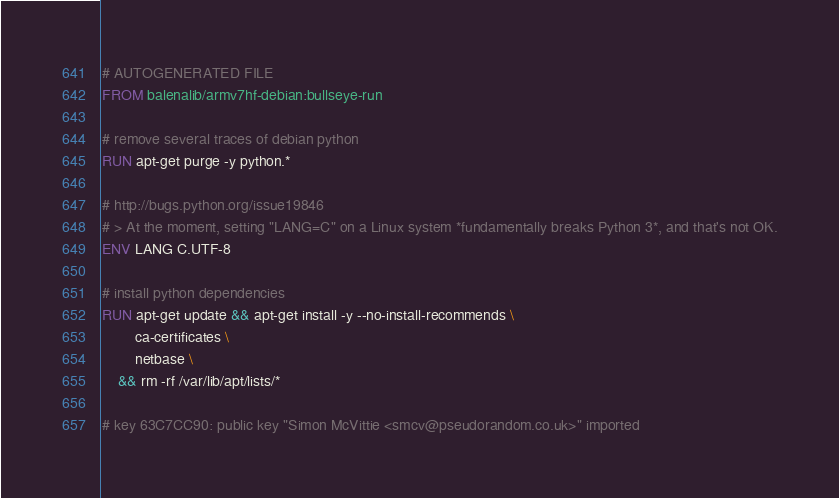<code> <loc_0><loc_0><loc_500><loc_500><_Dockerfile_># AUTOGENERATED FILE
FROM balenalib/armv7hf-debian:bullseye-run

# remove several traces of debian python
RUN apt-get purge -y python.*

# http://bugs.python.org/issue19846
# > At the moment, setting "LANG=C" on a Linux system *fundamentally breaks Python 3*, and that's not OK.
ENV LANG C.UTF-8

# install python dependencies
RUN apt-get update && apt-get install -y --no-install-recommends \
		ca-certificates \
		netbase \
	&& rm -rf /var/lib/apt/lists/*

# key 63C7CC90: public key "Simon McVittie <smcv@pseudorandom.co.uk>" imported</code> 